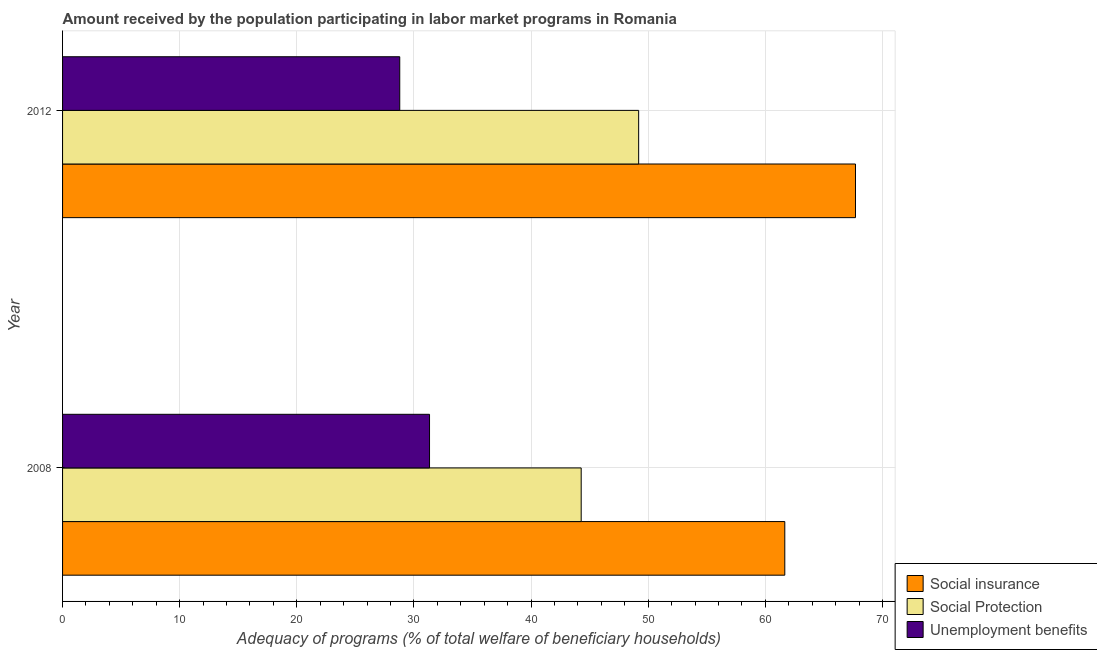How many different coloured bars are there?
Your response must be concise. 3. Are the number of bars per tick equal to the number of legend labels?
Provide a succinct answer. Yes. How many bars are there on the 2nd tick from the top?
Give a very brief answer. 3. What is the amount received by the population participating in social protection programs in 2012?
Your answer should be compact. 49.18. Across all years, what is the maximum amount received by the population participating in unemployment benefits programs?
Your answer should be very brief. 31.33. Across all years, what is the minimum amount received by the population participating in social insurance programs?
Provide a succinct answer. 61.66. In which year was the amount received by the population participating in social protection programs minimum?
Provide a succinct answer. 2008. What is the total amount received by the population participating in unemployment benefits programs in the graph?
Give a very brief answer. 60.12. What is the difference between the amount received by the population participating in unemployment benefits programs in 2008 and that in 2012?
Offer a terse response. 2.54. What is the difference between the amount received by the population participating in social protection programs in 2008 and the amount received by the population participating in social insurance programs in 2012?
Offer a terse response. -23.42. What is the average amount received by the population participating in unemployment benefits programs per year?
Provide a short and direct response. 30.06. In the year 2012, what is the difference between the amount received by the population participating in social insurance programs and amount received by the population participating in social protection programs?
Provide a short and direct response. 18.51. What is the ratio of the amount received by the population participating in unemployment benefits programs in 2008 to that in 2012?
Give a very brief answer. 1.09. Is the amount received by the population participating in social insurance programs in 2008 less than that in 2012?
Your answer should be very brief. Yes. Is the difference between the amount received by the population participating in social protection programs in 2008 and 2012 greater than the difference between the amount received by the population participating in social insurance programs in 2008 and 2012?
Make the answer very short. Yes. In how many years, is the amount received by the population participating in social protection programs greater than the average amount received by the population participating in social protection programs taken over all years?
Keep it short and to the point. 1. What does the 2nd bar from the top in 2012 represents?
Offer a terse response. Social Protection. What does the 2nd bar from the bottom in 2008 represents?
Keep it short and to the point. Social Protection. Is it the case that in every year, the sum of the amount received by the population participating in social insurance programs and amount received by the population participating in social protection programs is greater than the amount received by the population participating in unemployment benefits programs?
Ensure brevity in your answer.  Yes. Are all the bars in the graph horizontal?
Your answer should be compact. Yes. How many years are there in the graph?
Provide a short and direct response. 2. What is the difference between two consecutive major ticks on the X-axis?
Provide a succinct answer. 10. How many legend labels are there?
Offer a terse response. 3. What is the title of the graph?
Provide a short and direct response. Amount received by the population participating in labor market programs in Romania. Does "Transport" appear as one of the legend labels in the graph?
Your response must be concise. No. What is the label or title of the X-axis?
Provide a succinct answer. Adequacy of programs (% of total welfare of beneficiary households). What is the label or title of the Y-axis?
Offer a terse response. Year. What is the Adequacy of programs (% of total welfare of beneficiary households) of Social insurance in 2008?
Give a very brief answer. 61.66. What is the Adequacy of programs (% of total welfare of beneficiary households) of Social Protection in 2008?
Your answer should be compact. 44.28. What is the Adequacy of programs (% of total welfare of beneficiary households) in Unemployment benefits in 2008?
Ensure brevity in your answer.  31.33. What is the Adequacy of programs (% of total welfare of beneficiary households) of Social insurance in 2012?
Offer a terse response. 67.7. What is the Adequacy of programs (% of total welfare of beneficiary households) in Social Protection in 2012?
Offer a terse response. 49.18. What is the Adequacy of programs (% of total welfare of beneficiary households) of Unemployment benefits in 2012?
Make the answer very short. 28.79. Across all years, what is the maximum Adequacy of programs (% of total welfare of beneficiary households) of Social insurance?
Make the answer very short. 67.7. Across all years, what is the maximum Adequacy of programs (% of total welfare of beneficiary households) of Social Protection?
Your answer should be compact. 49.18. Across all years, what is the maximum Adequacy of programs (% of total welfare of beneficiary households) of Unemployment benefits?
Offer a terse response. 31.33. Across all years, what is the minimum Adequacy of programs (% of total welfare of beneficiary households) of Social insurance?
Provide a short and direct response. 61.66. Across all years, what is the minimum Adequacy of programs (% of total welfare of beneficiary households) of Social Protection?
Offer a very short reply. 44.28. Across all years, what is the minimum Adequacy of programs (% of total welfare of beneficiary households) of Unemployment benefits?
Make the answer very short. 28.79. What is the total Adequacy of programs (% of total welfare of beneficiary households) of Social insurance in the graph?
Provide a short and direct response. 129.36. What is the total Adequacy of programs (% of total welfare of beneficiary households) of Social Protection in the graph?
Your answer should be compact. 93.46. What is the total Adequacy of programs (% of total welfare of beneficiary households) of Unemployment benefits in the graph?
Keep it short and to the point. 60.12. What is the difference between the Adequacy of programs (% of total welfare of beneficiary households) of Social insurance in 2008 and that in 2012?
Offer a very short reply. -6.04. What is the difference between the Adequacy of programs (% of total welfare of beneficiary households) of Social Protection in 2008 and that in 2012?
Provide a succinct answer. -4.91. What is the difference between the Adequacy of programs (% of total welfare of beneficiary households) of Unemployment benefits in 2008 and that in 2012?
Your response must be concise. 2.54. What is the difference between the Adequacy of programs (% of total welfare of beneficiary households) in Social insurance in 2008 and the Adequacy of programs (% of total welfare of beneficiary households) in Social Protection in 2012?
Give a very brief answer. 12.48. What is the difference between the Adequacy of programs (% of total welfare of beneficiary households) in Social insurance in 2008 and the Adequacy of programs (% of total welfare of beneficiary households) in Unemployment benefits in 2012?
Your response must be concise. 32.87. What is the difference between the Adequacy of programs (% of total welfare of beneficiary households) in Social Protection in 2008 and the Adequacy of programs (% of total welfare of beneficiary households) in Unemployment benefits in 2012?
Offer a very short reply. 15.49. What is the average Adequacy of programs (% of total welfare of beneficiary households) of Social insurance per year?
Offer a terse response. 64.68. What is the average Adequacy of programs (% of total welfare of beneficiary households) in Social Protection per year?
Your answer should be very brief. 46.73. What is the average Adequacy of programs (% of total welfare of beneficiary households) of Unemployment benefits per year?
Offer a very short reply. 30.06. In the year 2008, what is the difference between the Adequacy of programs (% of total welfare of beneficiary households) in Social insurance and Adequacy of programs (% of total welfare of beneficiary households) in Social Protection?
Offer a very short reply. 17.38. In the year 2008, what is the difference between the Adequacy of programs (% of total welfare of beneficiary households) in Social insurance and Adequacy of programs (% of total welfare of beneficiary households) in Unemployment benefits?
Your answer should be very brief. 30.33. In the year 2008, what is the difference between the Adequacy of programs (% of total welfare of beneficiary households) of Social Protection and Adequacy of programs (% of total welfare of beneficiary households) of Unemployment benefits?
Your answer should be compact. 12.95. In the year 2012, what is the difference between the Adequacy of programs (% of total welfare of beneficiary households) in Social insurance and Adequacy of programs (% of total welfare of beneficiary households) in Social Protection?
Offer a very short reply. 18.51. In the year 2012, what is the difference between the Adequacy of programs (% of total welfare of beneficiary households) in Social insurance and Adequacy of programs (% of total welfare of beneficiary households) in Unemployment benefits?
Offer a very short reply. 38.91. In the year 2012, what is the difference between the Adequacy of programs (% of total welfare of beneficiary households) of Social Protection and Adequacy of programs (% of total welfare of beneficiary households) of Unemployment benefits?
Offer a terse response. 20.4. What is the ratio of the Adequacy of programs (% of total welfare of beneficiary households) in Social insurance in 2008 to that in 2012?
Ensure brevity in your answer.  0.91. What is the ratio of the Adequacy of programs (% of total welfare of beneficiary households) in Social Protection in 2008 to that in 2012?
Give a very brief answer. 0.9. What is the ratio of the Adequacy of programs (% of total welfare of beneficiary households) of Unemployment benefits in 2008 to that in 2012?
Provide a succinct answer. 1.09. What is the difference between the highest and the second highest Adequacy of programs (% of total welfare of beneficiary households) of Social insurance?
Your answer should be very brief. 6.04. What is the difference between the highest and the second highest Adequacy of programs (% of total welfare of beneficiary households) in Social Protection?
Your answer should be very brief. 4.91. What is the difference between the highest and the second highest Adequacy of programs (% of total welfare of beneficiary households) in Unemployment benefits?
Your answer should be very brief. 2.54. What is the difference between the highest and the lowest Adequacy of programs (% of total welfare of beneficiary households) of Social insurance?
Your answer should be very brief. 6.04. What is the difference between the highest and the lowest Adequacy of programs (% of total welfare of beneficiary households) of Social Protection?
Provide a short and direct response. 4.91. What is the difference between the highest and the lowest Adequacy of programs (% of total welfare of beneficiary households) of Unemployment benefits?
Your response must be concise. 2.54. 